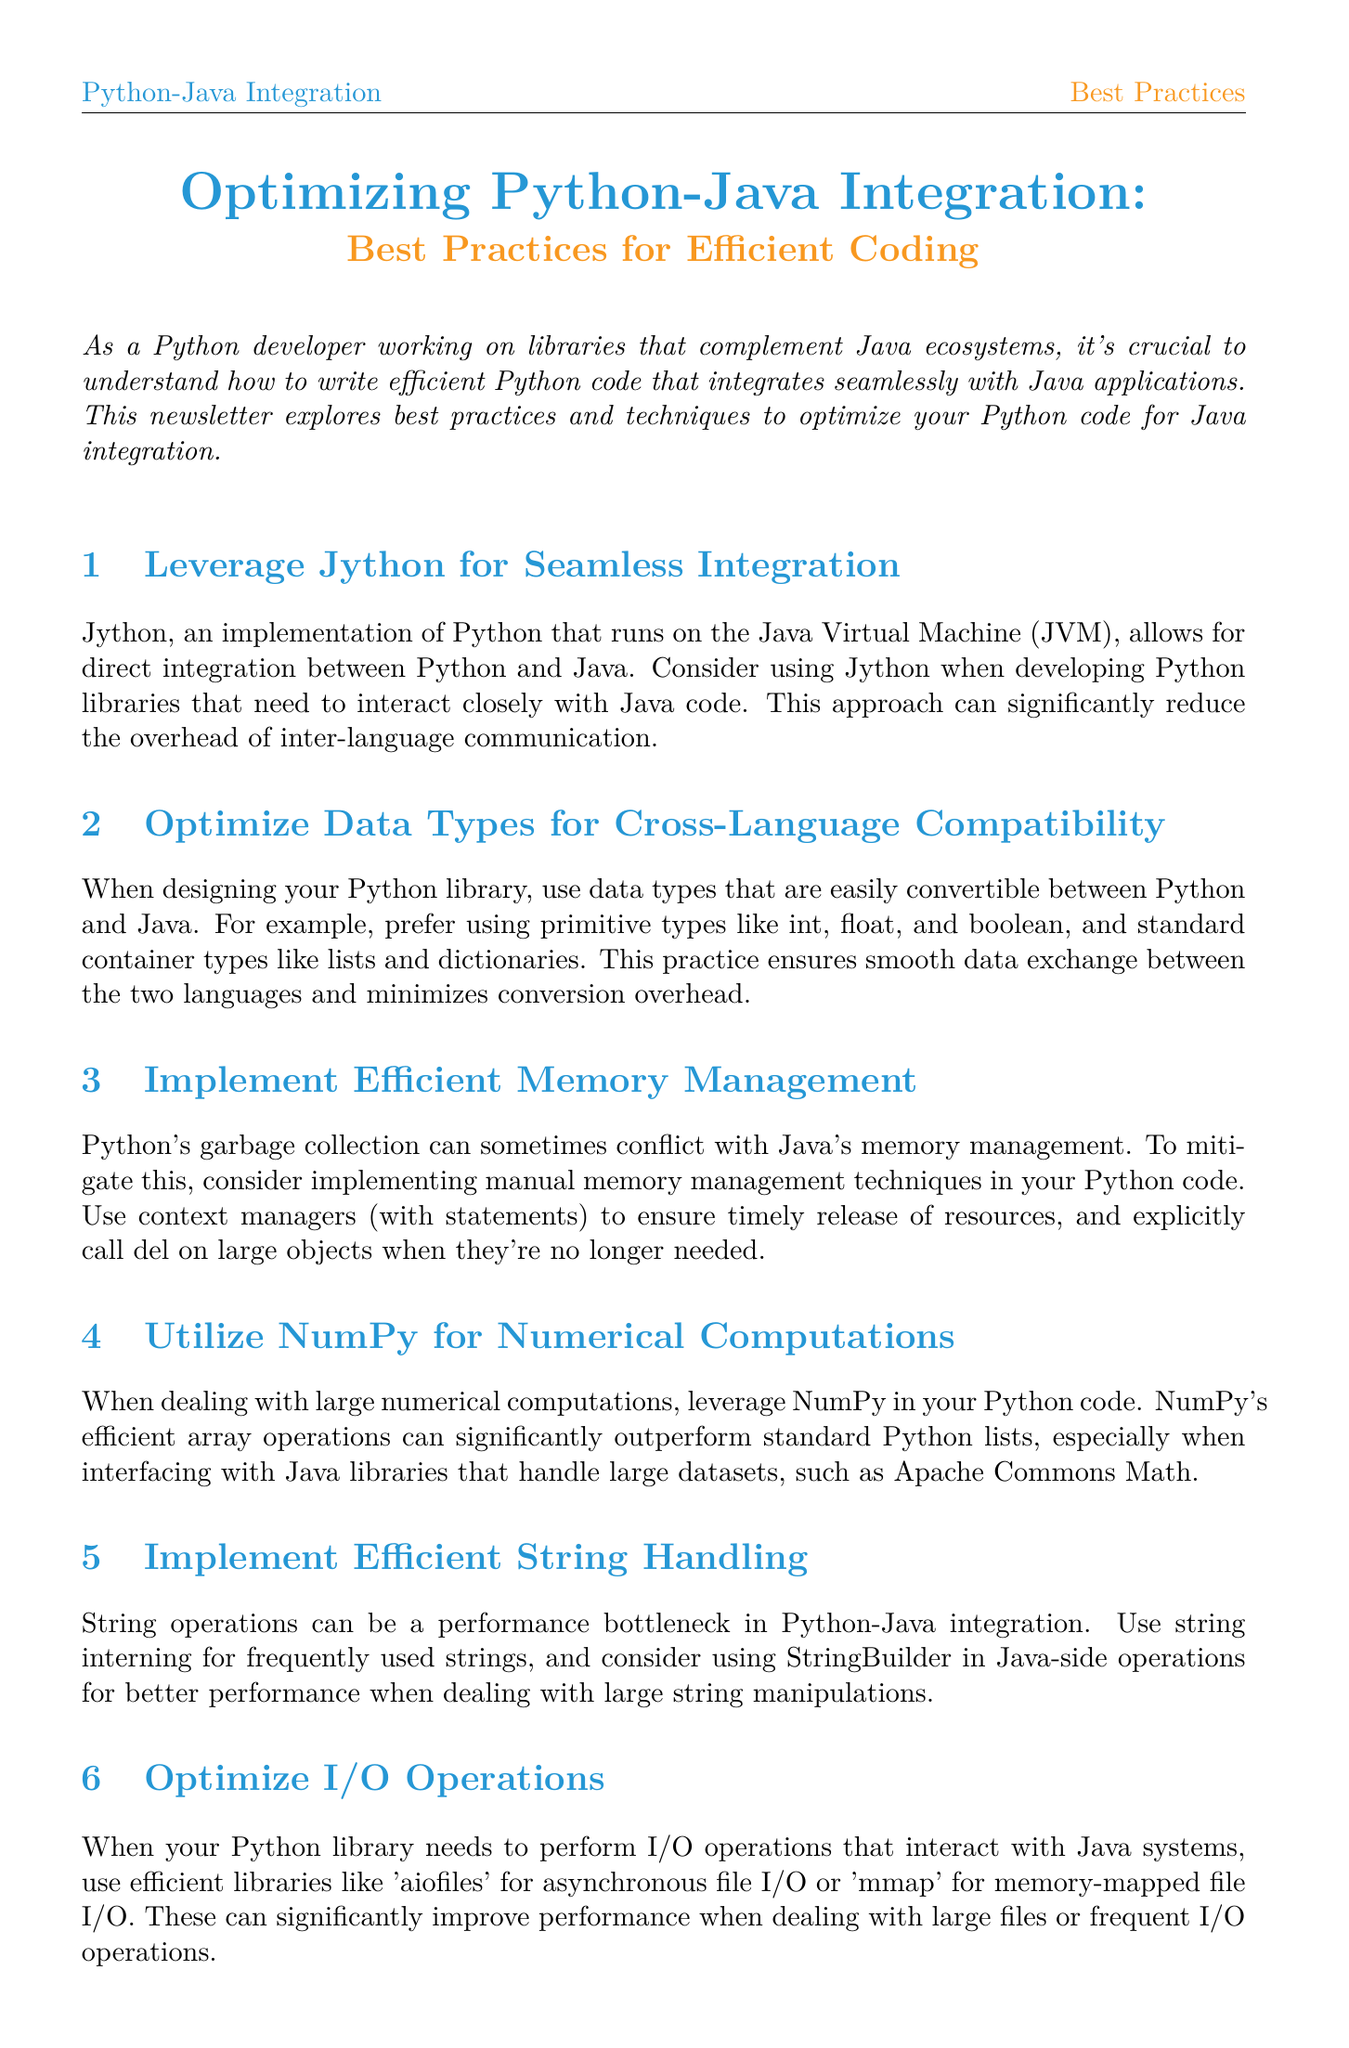What is the title of the newsletter? The title of the newsletter is mentioned at the beginning of the document, and it is "Optimizing Python-Java Integration: Best Practices for Efficient Coding."
Answer: Optimizing Python-Java Integration: Best Practices for Efficient Coding What is one recommended tool for seamless integration of Python with Java? The document suggests using Jython for seamless integration of Python with Java applications.
Answer: Jython Which data types should be preferred for cross-language compatibility? The document specifically mentions using primitive types like int, float, and boolean as preferred data types for cross-language compatibility.
Answer: int, float, and boolean What method should be used to manage memory effectively in Python? The newsletter recommends using context managers (with statements) for effective memory management in Python.
Answer: context managers What performance improvement percentage was achieved in the case study? The case study in the document states that a 40% improvement was achieved in processing speed for distributed computing tasks.
Answer: 40% Which library is suggested for numerical computations in Python? The document suggests using NumPy for efficient numerical computations in Python.
Answer: NumPy What type of operations can be optimized with the 'aiofiles' library? The newsletter indicates that 'aiofiles' is used to optimize asynchronous file I/O operations.
Answer: asynchronous file I/O How should string operations be handled to improve performance? The document states that string interning should be used for frequently used strings to handle string operations efficiently.
Answer: string interning What is the focus of the case study presented in the newsletter? The case study focuses on optimizing PySpark for better integration with a Java-based Apache Spark ecosystem.
Answer: Optimizing PySpark for Java Integration 